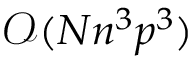<formula> <loc_0><loc_0><loc_500><loc_500>\mathcal { O } ( N n ^ { 3 } p ^ { 3 } )</formula> 